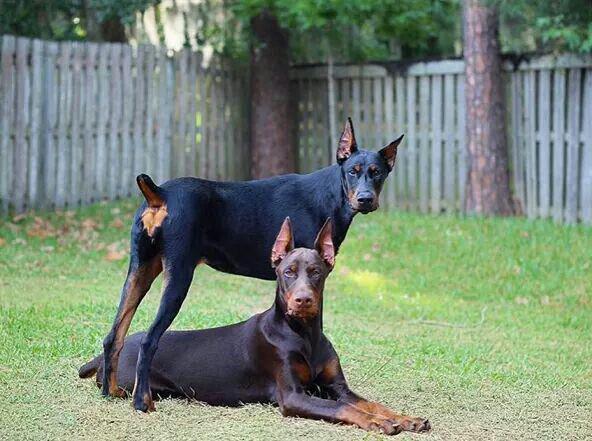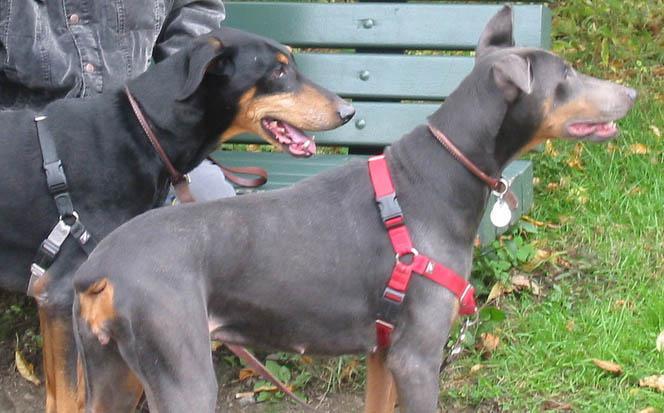The first image is the image on the left, the second image is the image on the right. Analyze the images presented: Is the assertion "The right image contains exactly two dogs." valid? Answer yes or no. Yes. 